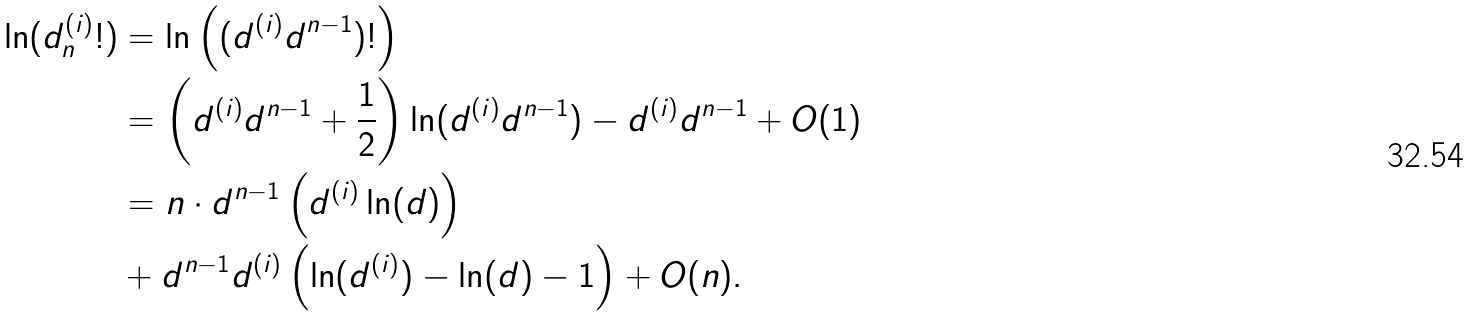Convert formula to latex. <formula><loc_0><loc_0><loc_500><loc_500>\ln ( d _ { n } ^ { ( i ) } ! ) & = \ln \left ( ( d ^ { ( i ) } d ^ { n - 1 } ) ! \right ) \\ & = \left ( d ^ { ( i ) } d ^ { n - 1 } + \frac { 1 } { 2 } \right ) \ln ( d ^ { ( i ) } d ^ { n - 1 } ) - d ^ { ( i ) } d ^ { n - 1 } + O ( 1 ) \\ & = n \cdot d ^ { n - 1 } \left ( d ^ { ( i ) } \ln ( d ) \right ) \\ & + d ^ { n - 1 } d ^ { ( i ) } \left ( \ln ( d ^ { ( i ) } ) - \ln ( d ) - 1 \right ) + O ( n ) .</formula> 